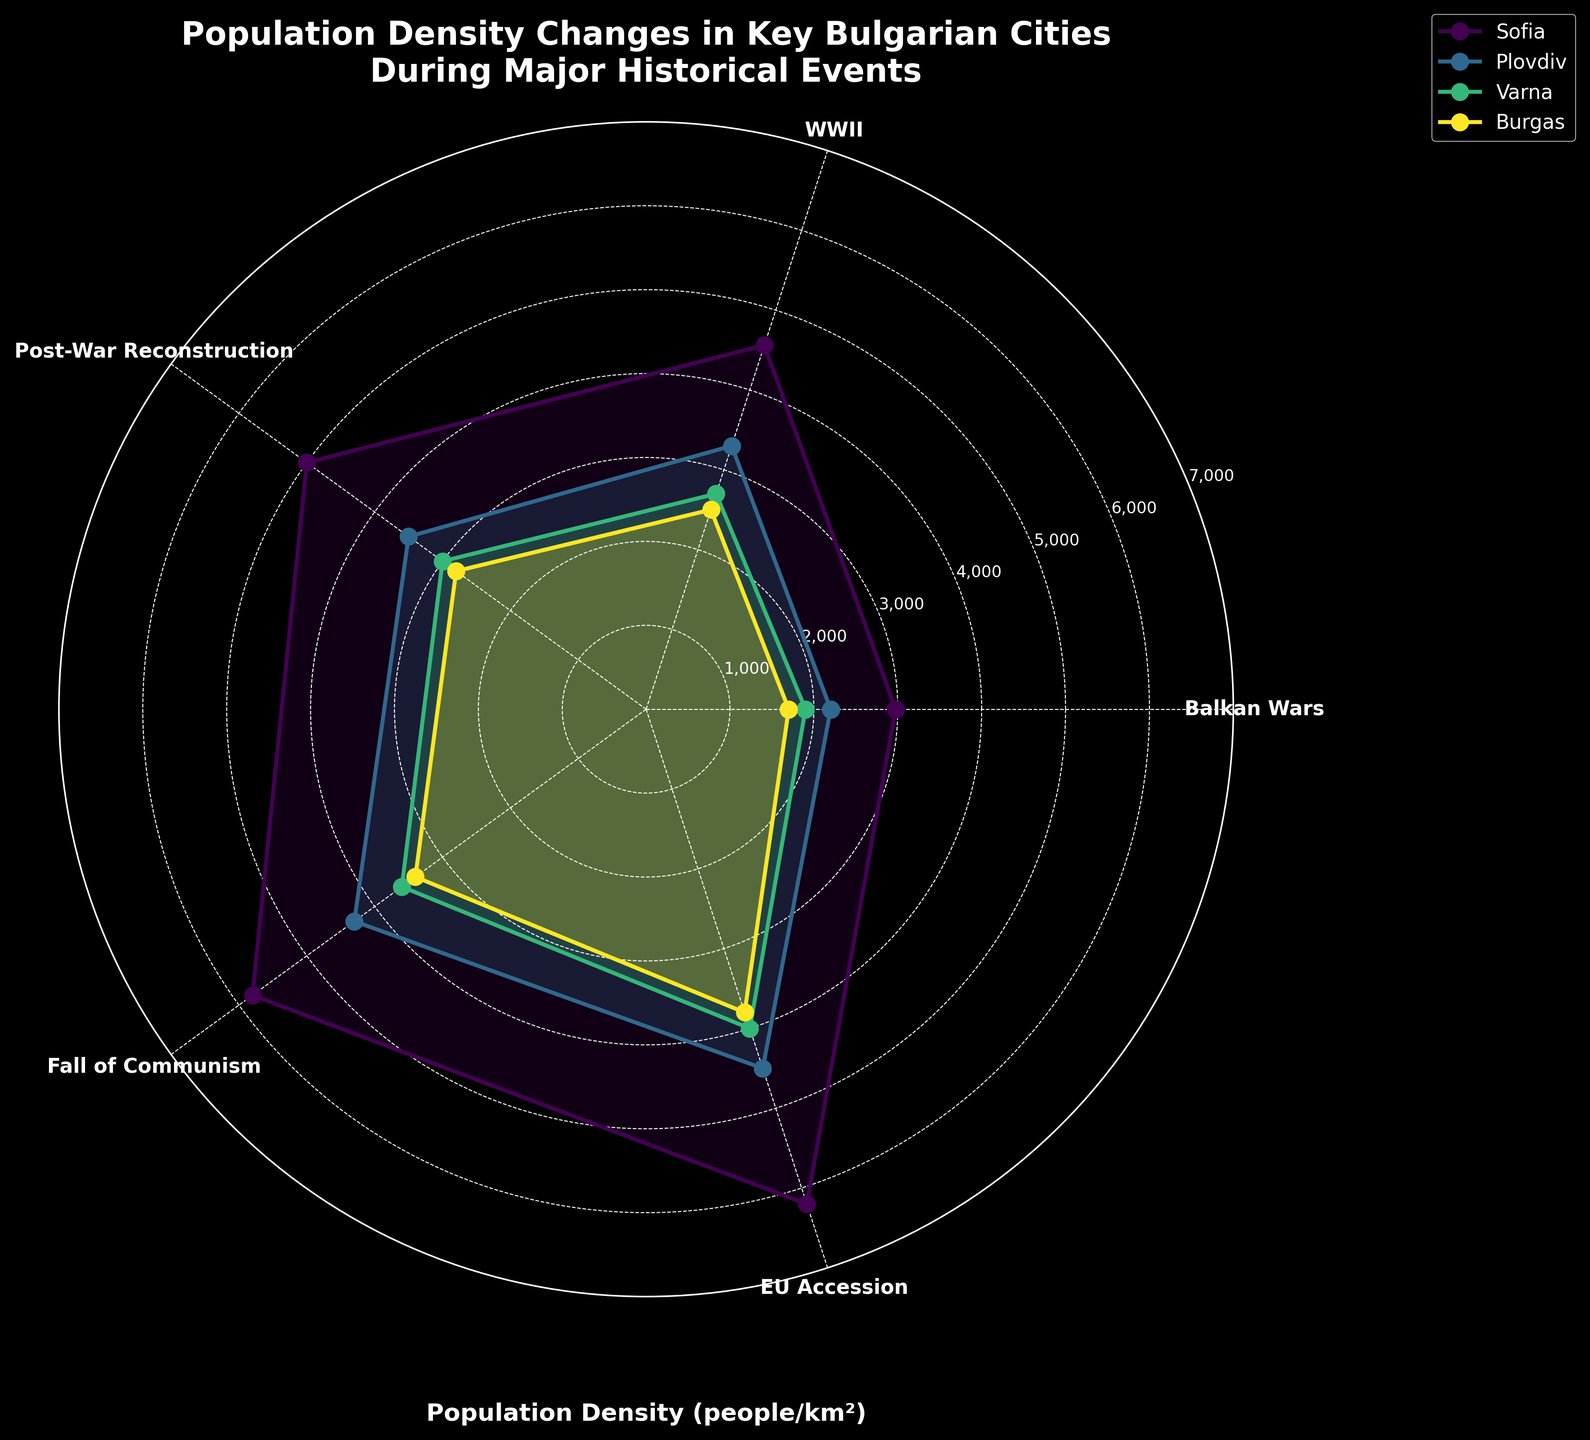What's the title of the chart? The title is typically written at the top of the figure. It provides context to the reader about what the chart is depicting.
Answer: 'Population Density Changes in Key Bulgarian Cities During Major Historical Events' How many cities are represented in the chart? Count the number of unique lines or labels in the legend, which correspond to the different cities.
Answer: Four Which event saw the highest population density increase in Sofia? Compare the population density values for Sofia across different events. Identify the event with the largest increase in population density.
Answer: EU Accession, 2007 What was the population density of Varna during the Balkan Wars? Refer to the plot line or label associated with Varna and locate the point corresponding to the Balkan Wars.
Answer: 1900 people/km² How does the population density of Burgas in 1950 compare to that of Plovdiv in the same year? Check the population density values for both Burgas and Plovdiv in 1950 and compare them.
Answer: Burgas had 2800 people/km², and Plovdiv had 3500 people/km² Which city had the lowest population density during WWII? Examine the plotted points for all the cities during WWII and identify the one with the lowest value.
Answer: Burgas What's the average population density of Sofia across all events? Add the population density values for Sofia across all events and divide by the number of events.
Answer: (2975 + 4562 + 5000 + 5800 + 6200) / 5 = 4907.4 people/km² During which event did Plovdiv have the closest population density to Varna's population density during the Fall of Communism? Locate Varna's population density during the Fall of Communism (1989), then find the event where Plovdiv's population density most closely matches that value.
Answer: Plovdiv during Post-War Reconstruction, 1950 (3500 people/km² vs 3600 people/km²) What is the gap in population density between Sofia and Burgas during the EU Accession? Subtract the population density of Burgas from that of Sofia for the event of EU Accession.
Answer: 6200 - 3800 = 2400 people/km² In which city did the population density stay relatively stable between the Fall of Communism and EU Accession? Compare the population density changes from the Fall of Communism to EU Accession for all cities and identify the city with the smallest change.
Answer: Plovdiv (4300 to 4500, a change of 200 people/km²) 